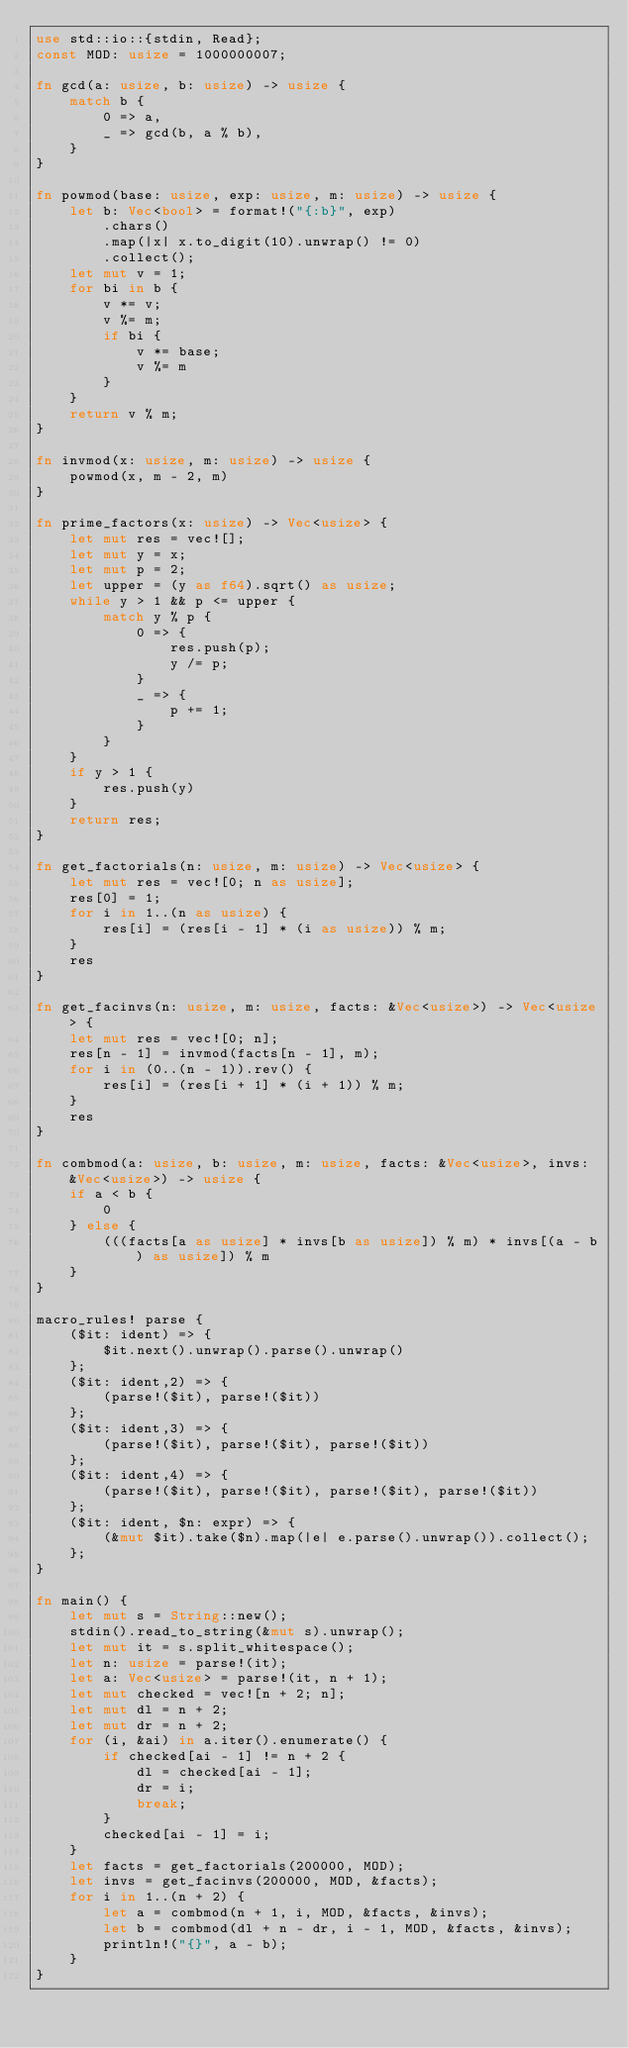Convert code to text. <code><loc_0><loc_0><loc_500><loc_500><_Rust_>use std::io::{stdin, Read};
const MOD: usize = 1000000007;

fn gcd(a: usize, b: usize) -> usize {
    match b {
        0 => a,
        _ => gcd(b, a % b),
    }
}

fn powmod(base: usize, exp: usize, m: usize) -> usize {
    let b: Vec<bool> = format!("{:b}", exp)
        .chars()
        .map(|x| x.to_digit(10).unwrap() != 0)
        .collect();
    let mut v = 1;
    for bi in b {
        v *= v;
        v %= m;
        if bi {
            v *= base;
            v %= m
        }
    }
    return v % m;
}

fn invmod(x: usize, m: usize) -> usize {
    powmod(x, m - 2, m)
}

fn prime_factors(x: usize) -> Vec<usize> {
    let mut res = vec![];
    let mut y = x;
    let mut p = 2;
    let upper = (y as f64).sqrt() as usize;
    while y > 1 && p <= upper {
        match y % p {
            0 => {
                res.push(p);
                y /= p;
            }
            _ => {
                p += 1;
            }
        }
    }
    if y > 1 {
        res.push(y)
    }
    return res;
}

fn get_factorials(n: usize, m: usize) -> Vec<usize> {
    let mut res = vec![0; n as usize];
    res[0] = 1;
    for i in 1..(n as usize) {
        res[i] = (res[i - 1] * (i as usize)) % m;
    }
    res
}

fn get_facinvs(n: usize, m: usize, facts: &Vec<usize>) -> Vec<usize> {
    let mut res = vec![0; n];
    res[n - 1] = invmod(facts[n - 1], m);
    for i in (0..(n - 1)).rev() {
        res[i] = (res[i + 1] * (i + 1)) % m;
    }
    res
}

fn combmod(a: usize, b: usize, m: usize, facts: &Vec<usize>, invs: &Vec<usize>) -> usize {
    if a < b {
        0
    } else {
        (((facts[a as usize] * invs[b as usize]) % m) * invs[(a - b) as usize]) % m
    }
}

macro_rules! parse {
    ($it: ident) => {
        $it.next().unwrap().parse().unwrap()
    };
    ($it: ident,2) => {
        (parse!($it), parse!($it))
    };
    ($it: ident,3) => {
        (parse!($it), parse!($it), parse!($it))
    };
    ($it: ident,4) => {
        (parse!($it), parse!($it), parse!($it), parse!($it))
    };
    ($it: ident, $n: expr) => {
        (&mut $it).take($n).map(|e| e.parse().unwrap()).collect();
    };
}

fn main() {
    let mut s = String::new();
    stdin().read_to_string(&mut s).unwrap();
    let mut it = s.split_whitespace();
    let n: usize = parse!(it);
    let a: Vec<usize> = parse!(it, n + 1);
    let mut checked = vec![n + 2; n];
    let mut dl = n + 2;
    let mut dr = n + 2;
    for (i, &ai) in a.iter().enumerate() {
        if checked[ai - 1] != n + 2 {
            dl = checked[ai - 1];
            dr = i;
            break;
        }
        checked[ai - 1] = i;
    }
    let facts = get_factorials(200000, MOD);
    let invs = get_facinvs(200000, MOD, &facts);
    for i in 1..(n + 2) {
        let a = combmod(n + 1, i, MOD, &facts, &invs);
        let b = combmod(dl + n - dr, i - 1, MOD, &facts, &invs);
        println!("{}", a - b);
    }
}
</code> 